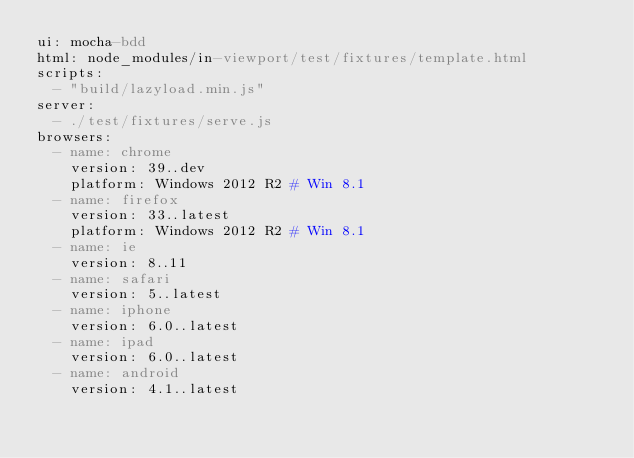Convert code to text. <code><loc_0><loc_0><loc_500><loc_500><_YAML_>ui: mocha-bdd
html: node_modules/in-viewport/test/fixtures/template.html
scripts:
  - "build/lazyload.min.js"
server:
  - ./test/fixtures/serve.js
browsers:
  - name: chrome
    version: 39..dev
    platform: Windows 2012 R2 # Win 8.1
  - name: firefox
    version: 33..latest
    platform: Windows 2012 R2 # Win 8.1
  - name: ie
    version: 8..11
  - name: safari
    version: 5..latest
  - name: iphone
    version: 6.0..latest
  - name: ipad
    version: 6.0..latest
  - name: android
    version: 4.1..latest
</code> 